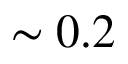<formula> <loc_0><loc_0><loc_500><loc_500>\sim 0 . 2</formula> 